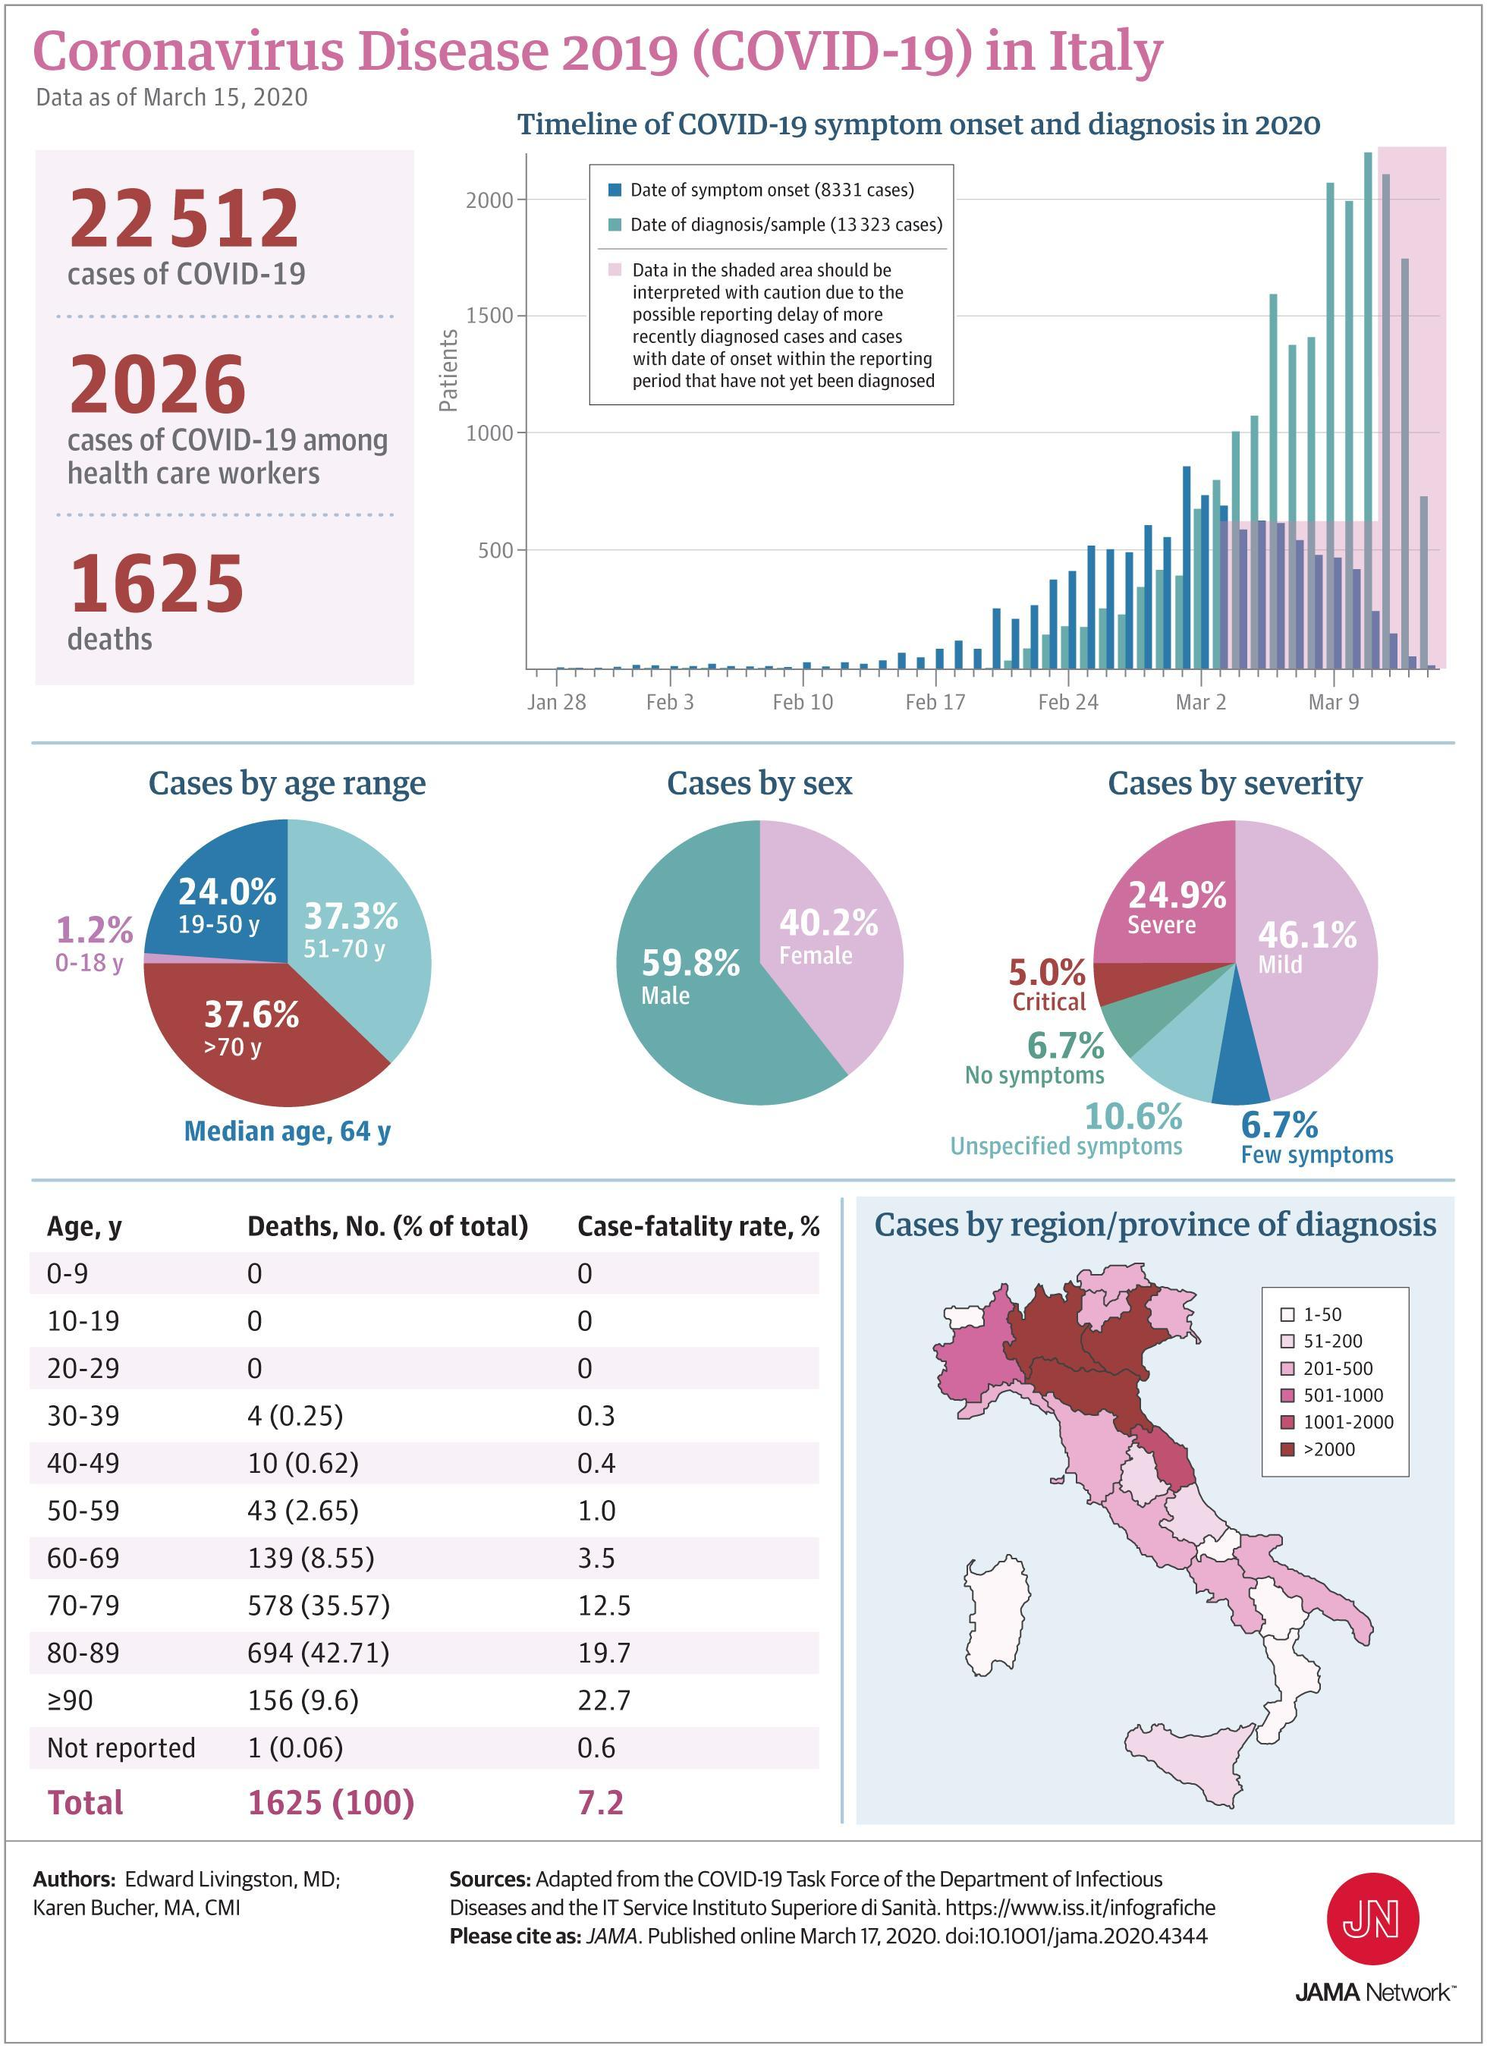What percent of people have mild symptoms of COVID-19 in Italy as of March 15, 2020?
Answer the question with a short phrase. 46.1% What percent of the infected people in Italy are males as of March 15, 2020? 59.8% How many Covid-19 deaths were reported in Italy as of March 15, 2020? 1625 What percent of the infected people in Italy are females as of March 15, 2020? 40.2% What is the case fatality rate of Covid-19 in the age group of 50-59 years in Italy as of March 15, 2020? 1.0 What percent of people have critical symptoms of COVID-19 in Italy as of March 15, 2020? 5.0% What is the case fatality rate of Covid-19 in the age group of 70-79 years in Italy as of March 15, 2020? 12.5 What percent of people have severe symptoms of COVID-19 in Italy as of March 15, 2020? 24.9% 